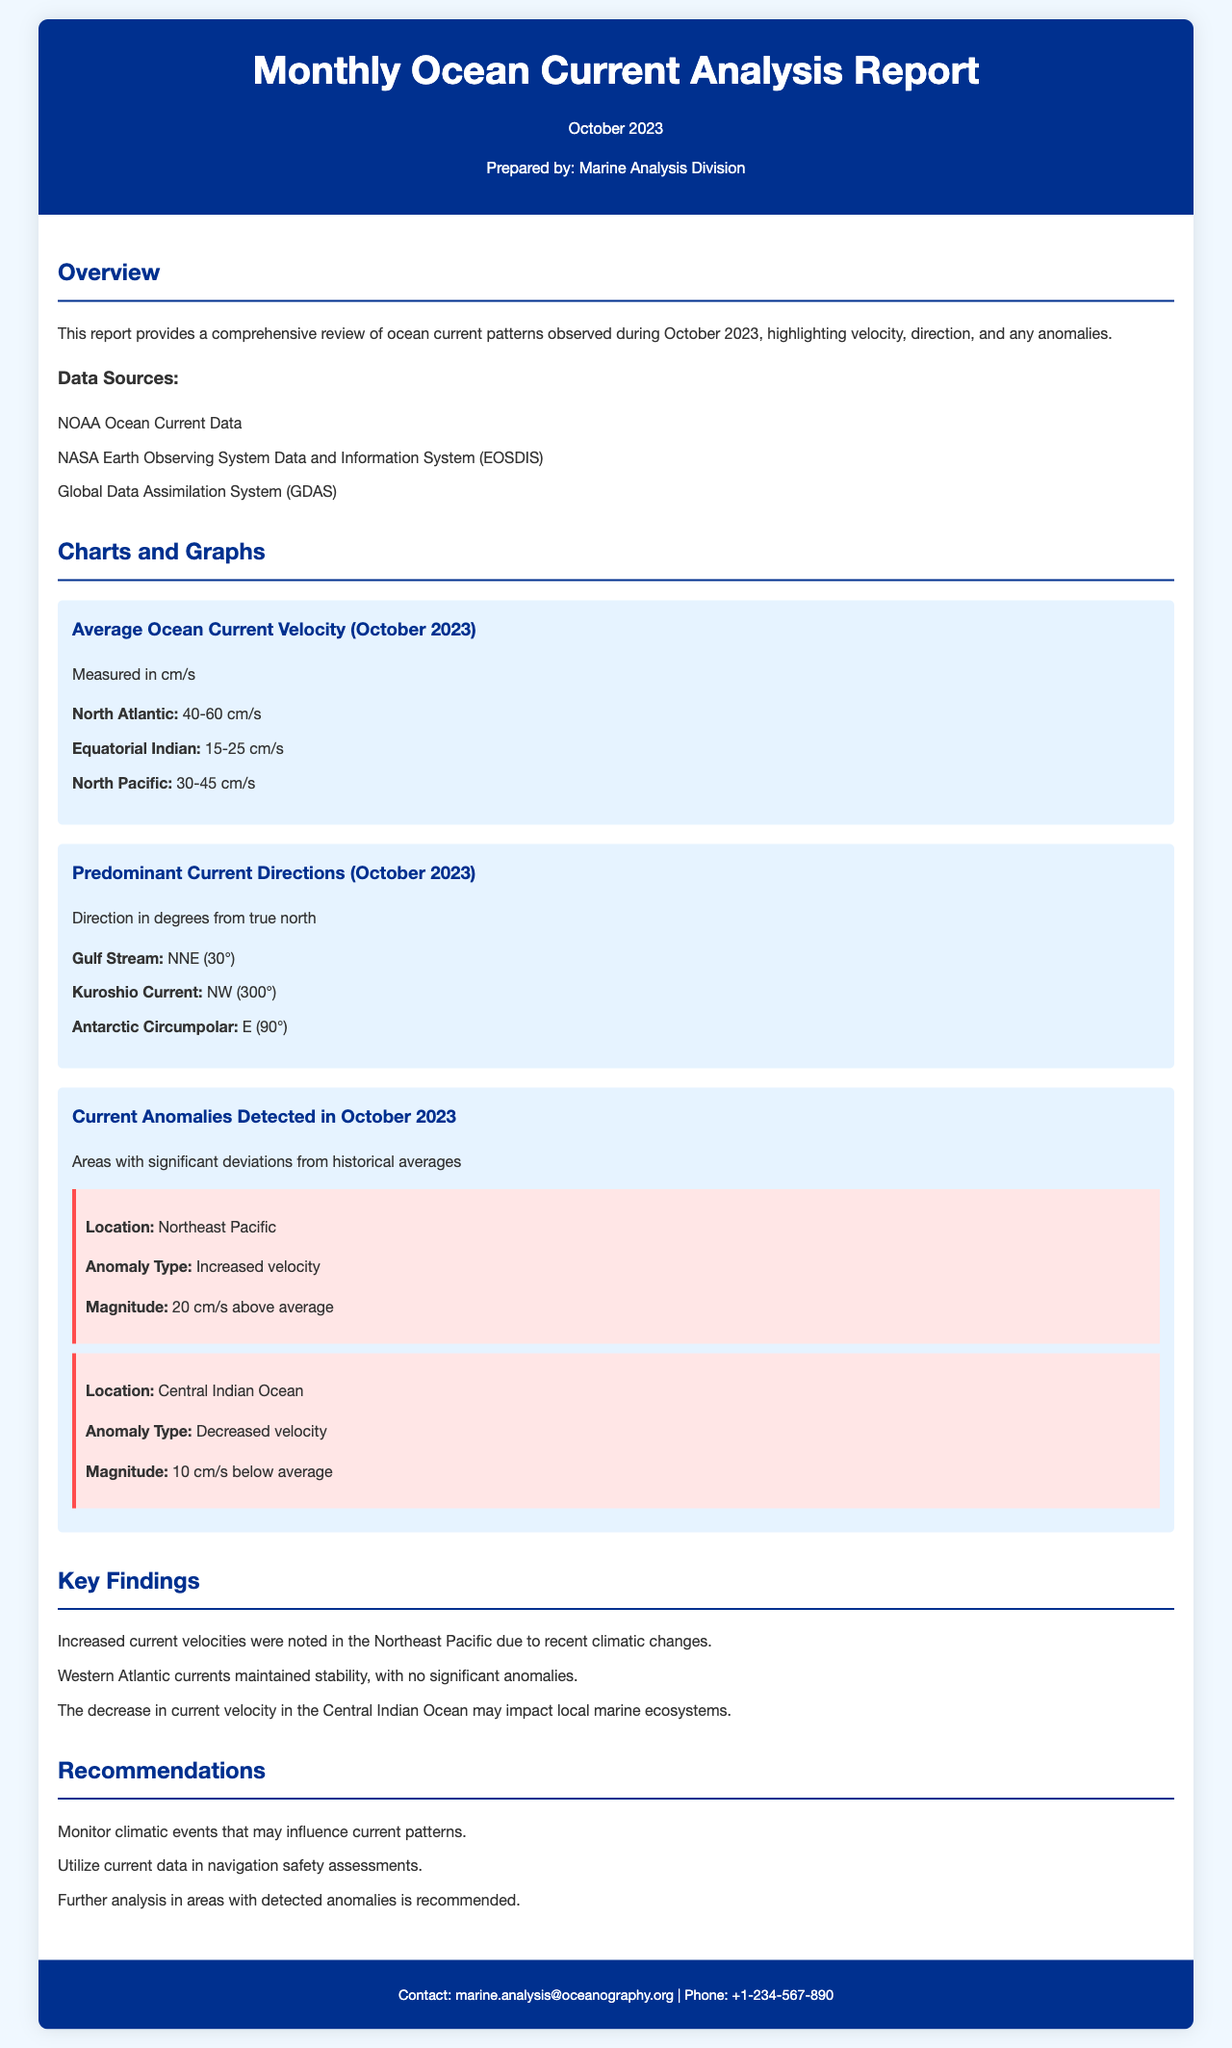What is the average velocity in the North Atlantic? The average velocity recorded for the North Atlantic is between 40 to 60 cm/s.
Answer: 40-60 cm/s What is the predominant direction of the Gulf Stream? The Gulf Stream predominately flows in the NNE direction, which is measured at 30 degrees from true north.
Answer: NNE (30°) How much is the anomaly in the Northeast Pacific? The anomaly in the Northeast Pacific indicates an increased velocity of 20 cm/s above average.
Answer: 20 cm/s above average What is the main concern regarding the current velocity in the Central Indian Ocean? The main concern is a decrease in current velocity, which might impact local marine ecosystems and has been observed at 10 cm/s below average.
Answer: Decreased velocity Who prepared the Monthly Ocean Current Analysis Report? The report was prepared by the Marine Analysis Division.
Answer: Marine Analysis Division What data source is listed first in the report? The first data source listed is NOAA Ocean Current Data.
Answer: NOAA Ocean Current Data 